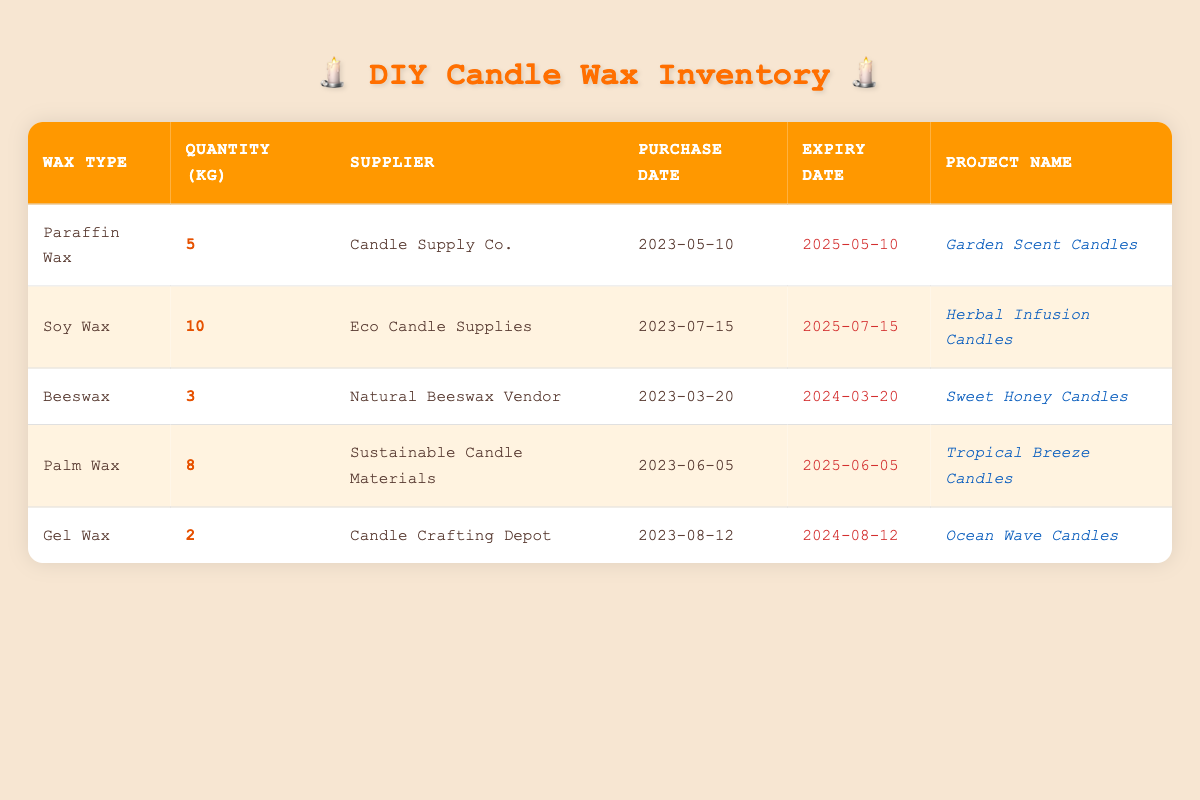What type of wax has the highest quantity in the inventory? The table lists the quantities of each wax type. By comparing the values, Soy Wax has the highest quantity at 10 kg.
Answer: Soy Wax Which supplier provided the Gel Wax? The table has a column for suppliers next to each wax type. The supplier for Gel Wax is Candle Crafting Depot.
Answer: Candle Crafting Depot What is the expiry date of the Beeswax? The table provides expiry dates for each wax type. For Beeswax, the date is listed as 2024-03-20.
Answer: 2024-03-20 How many kilograms of wax are available in total? To find the total, add the quantities for all types: 5 (Paraffin) + 10 (Soy) + 3 (Beeswax) + 8 (Palm) + 2 (Gel) = 28 kg.
Answer: 28 kg Is there any wax type that expires in less than a year from now? Checking the expiry dates in the table: Beeswax expires on 2024-03-20 and Gel Wax expires on 2024-08-12. Both are within a year from now, making the statement true.
Answer: Yes What is the average quantity of wax per project? There are 5 projects listed in the table. The total quantity of wax is 28 kg, so the average is 28 kg / 5 projects = 5.6 kg.
Answer: 5.6 kg For which project type has the supplier "Sustainable Candle Materials" provided wax? The project associated with Sustainable Candle Materials is Tropical Breeze Candles, as indicated in the table.
Answer: Tropical Breeze Candles Which wax type has the earliest purchase date? By examining the purchase dates, Beeswax has the earliest date of 2023-03-20, making it the first purchased wax type.
Answer: Beeswax What are the quantities of wax types that expire in the year 2024? Referring to the expiry dates, Beeswax (3 kg) and Gel Wax (2 kg) both expire in 2024, so the total for wax expiring in 2024 is 3 kg + 2 kg = 5 kg.
Answer: 5 kg 